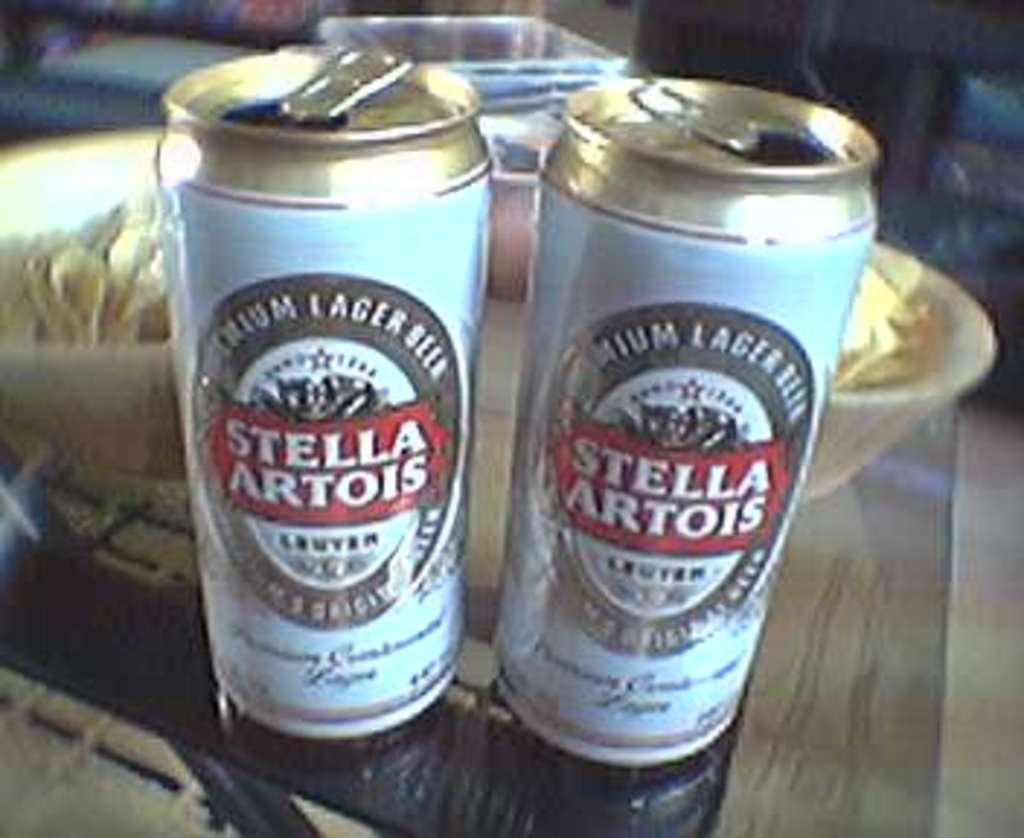<image>
Summarize the visual content of the image. Two cans of Stella Artois sit side by side. 